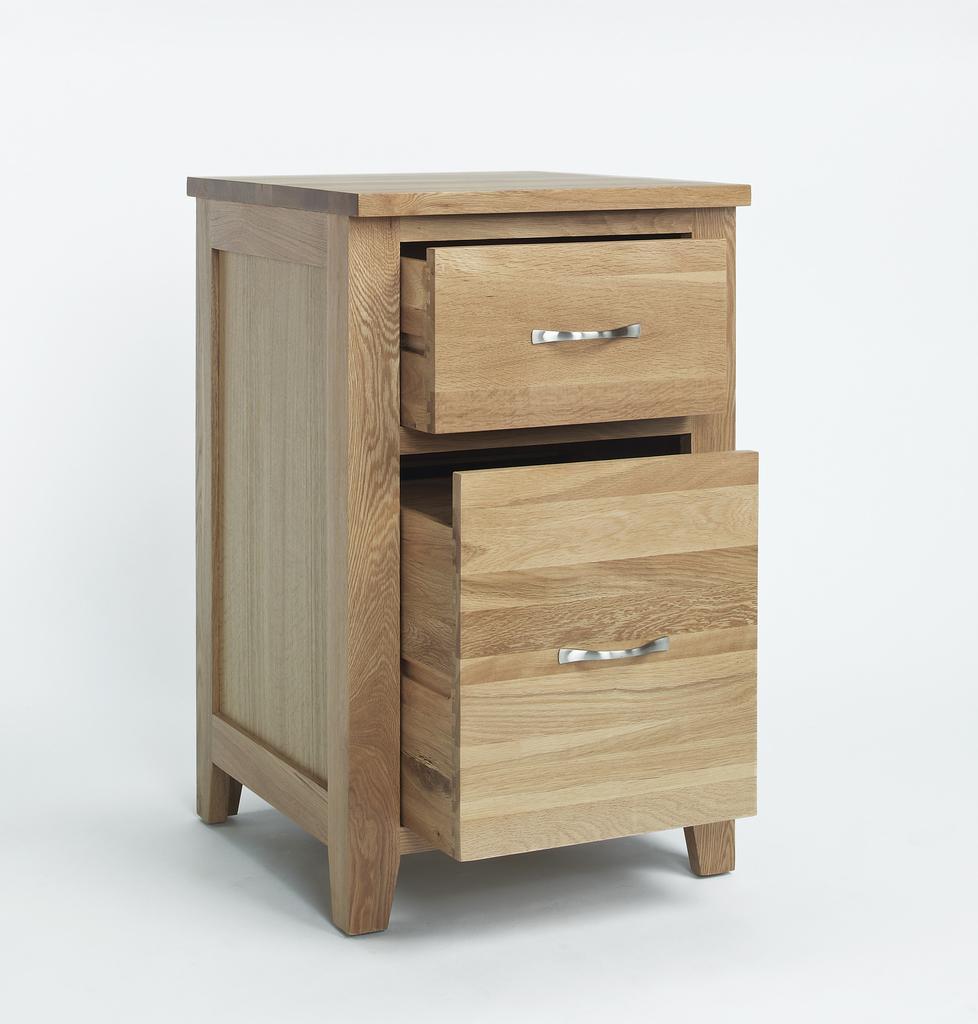Could you give a brief overview of what you see in this image? In the picture we can see a table with a two draws, it is prepared with a wooden, and handle with a metal, for this table there are four corners. 